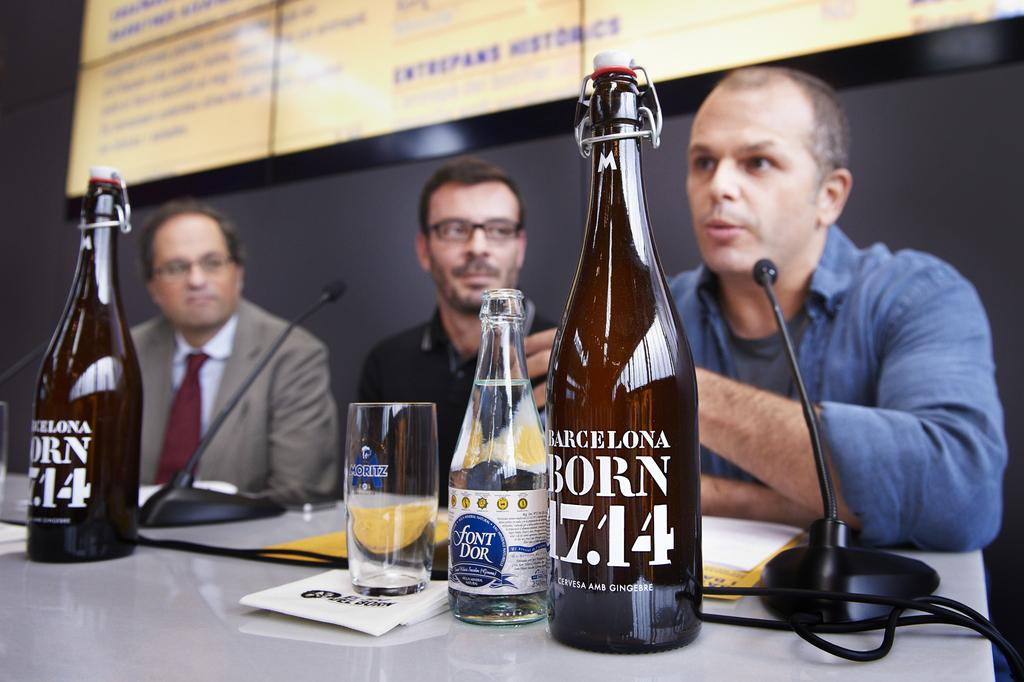<image>
Relay a brief, clear account of the picture shown. Men sit at a table with microphones and bottles that says 1714 in front of them. 